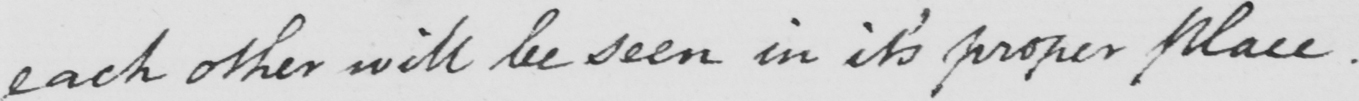Please provide the text content of this handwritten line. each other will be seen in its proper place . 